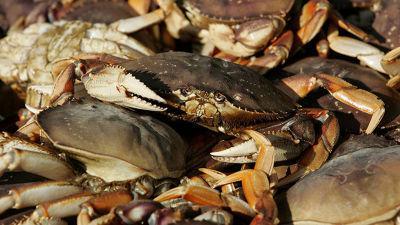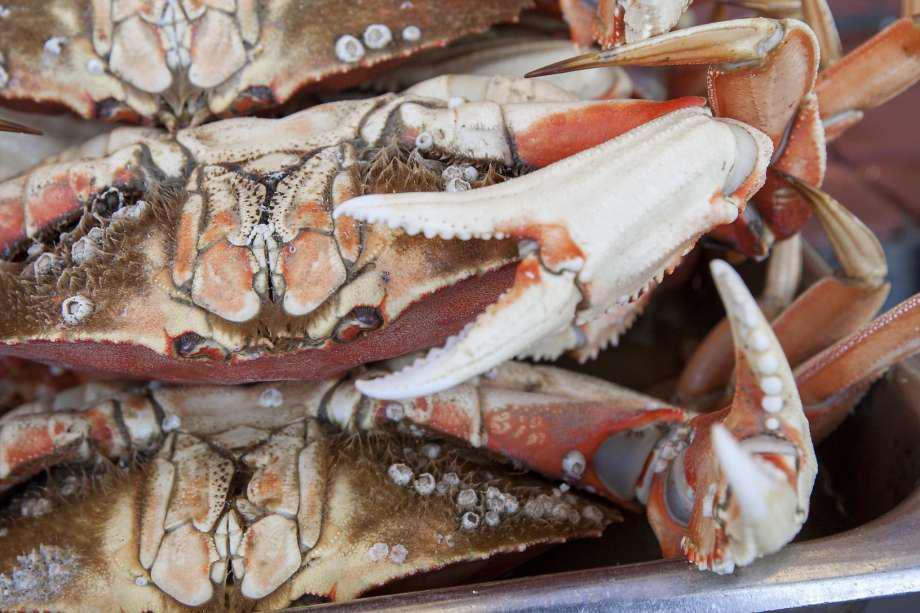The first image is the image on the left, the second image is the image on the right. Examine the images to the left and right. Is the description "there are 3 crabs stacked on top of each other, all three are upside down" accurate? Answer yes or no. Yes. The first image is the image on the left, the second image is the image on the right. Analyze the images presented: Is the assertion "There are three crabs stacked on top of each other." valid? Answer yes or no. Yes. 